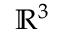<formula> <loc_0><loc_0><loc_500><loc_500>\mathbb { R } ^ { 3 }</formula> 